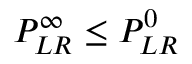<formula> <loc_0><loc_0><loc_500><loc_500>P _ { L R } ^ { \infty } \leq P _ { L R } ^ { 0 }</formula> 